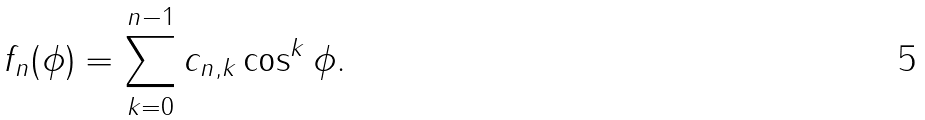<formula> <loc_0><loc_0><loc_500><loc_500>f _ { n } ( \phi ) = \sum _ { k = 0 } ^ { n - 1 } c _ { n , k } \cos ^ { k } \phi .</formula> 